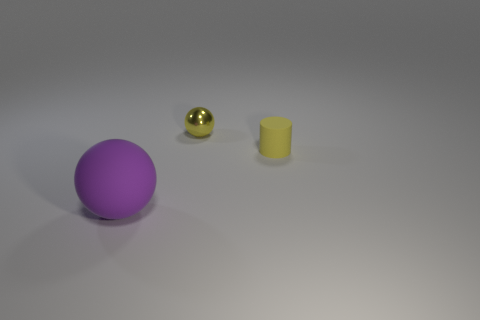How many other rubber objects are the same shape as the large purple object?
Your answer should be very brief. 0. What material is the tiny sphere that is the same color as the tiny matte object?
Provide a short and direct response. Metal. Are there any other things that are the same shape as the tiny matte thing?
Your answer should be very brief. No. What is the color of the sphere behind the matte thing in front of the matte thing on the right side of the big sphere?
Provide a short and direct response. Yellow. What number of large things are purple things or matte cylinders?
Provide a short and direct response. 1. Is the number of yellow metallic objects that are behind the small yellow rubber thing the same as the number of big yellow matte objects?
Offer a very short reply. No. Are there any purple matte balls in front of the yellow metallic object?
Your answer should be very brief. Yes. How many metallic objects are small yellow spheres or large red blocks?
Keep it short and to the point. 1. How many small yellow cylinders are to the right of the purple rubber sphere?
Offer a very short reply. 1. Are there any green objects of the same size as the metallic ball?
Make the answer very short. No. 